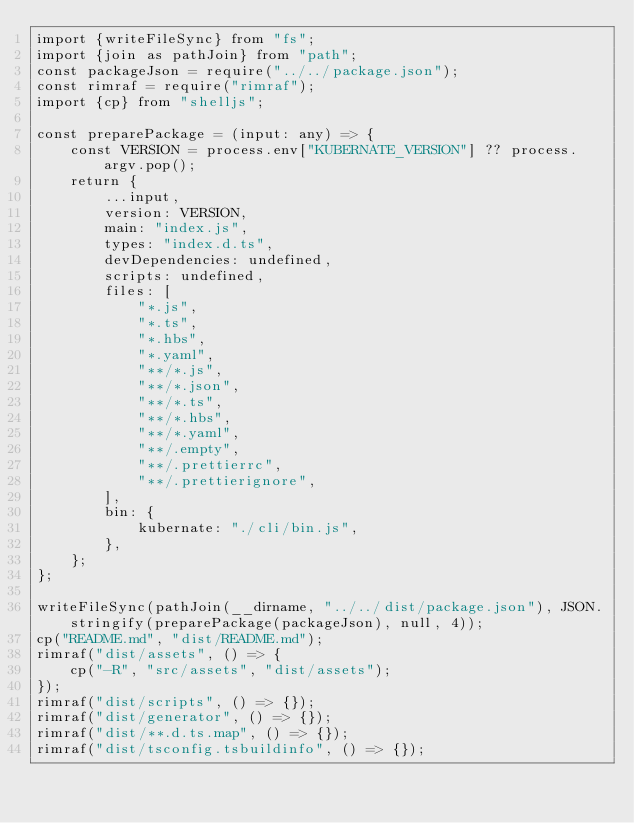Convert code to text. <code><loc_0><loc_0><loc_500><loc_500><_TypeScript_>import {writeFileSync} from "fs";
import {join as pathJoin} from "path";
const packageJson = require("../../package.json");
const rimraf = require("rimraf");
import {cp} from "shelljs";

const preparePackage = (input: any) => {
    const VERSION = process.env["KUBERNATE_VERSION"] ?? process.argv.pop();
    return {
        ...input,
        version: VERSION,
        main: "index.js",
        types: "index.d.ts",
        devDependencies: undefined,
        scripts: undefined,
        files: [
            "*.js",
            "*.ts",
            "*.hbs",
            "*.yaml",
            "**/*.js",
            "**/*.json",
            "**/*.ts",
            "**/*.hbs",
            "**/*.yaml",
            "**/.empty",
            "**/.prettierrc",
            "**/.prettierignore",
        ],
        bin: {
            kubernate: "./cli/bin.js",
        },
    };
};

writeFileSync(pathJoin(__dirname, "../../dist/package.json"), JSON.stringify(preparePackage(packageJson), null, 4));
cp("README.md", "dist/README.md");
rimraf("dist/assets", () => {
    cp("-R", "src/assets", "dist/assets");
});
rimraf("dist/scripts", () => {});
rimraf("dist/generator", () => {});
rimraf("dist/**.d.ts.map", () => {});
rimraf("dist/tsconfig.tsbuildinfo", () => {});
</code> 